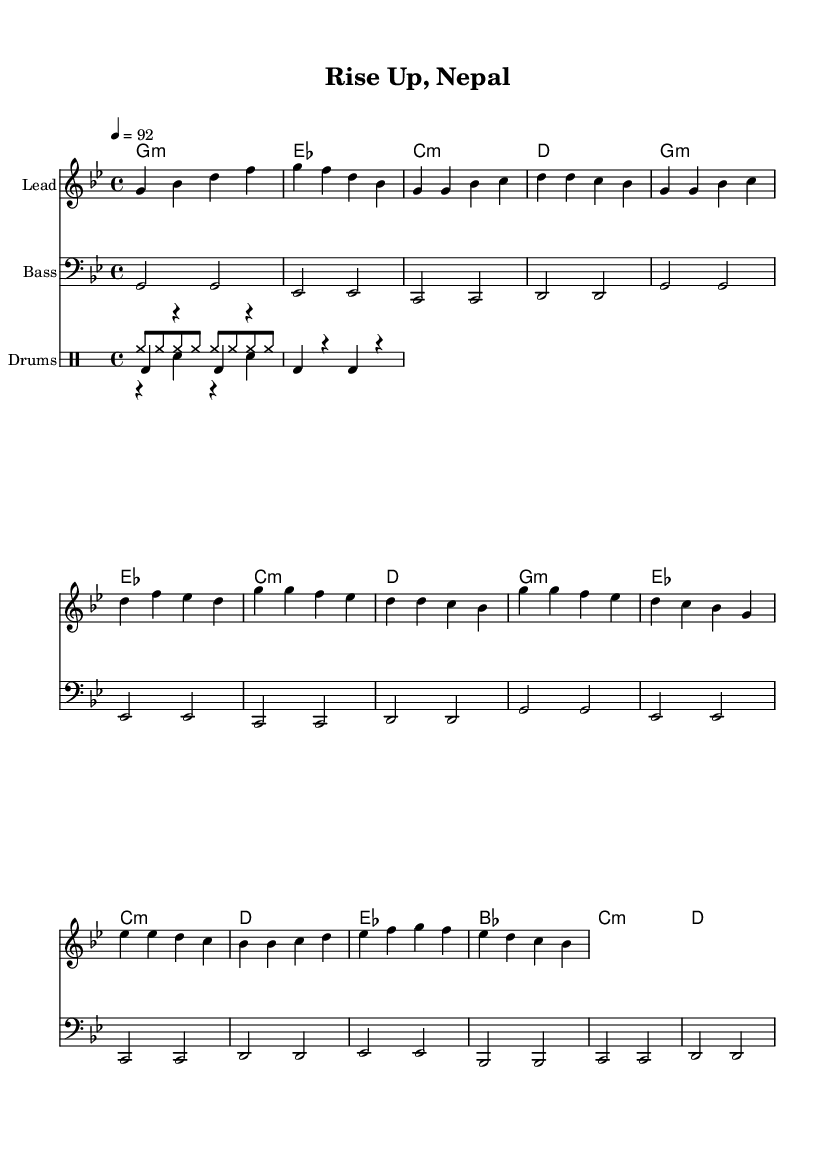What is the key signature of this music? The key signature is indicated at the beginning of the sheet music and shows two flats, which indicates B flat major or G minor.
Answer: G minor What is the time signature of the piece? The time signature is found at the beginning of the sheet music and is indicated as 4/4, meaning there are four beats in each measure, and the quarter note gets one beat.
Answer: 4/4 What is the tempo marking for this piece? The tempo marking is specified in the global section and indicates a speed of 92 beats per minute, meaning the piece should be played at this pace.
Answer: 92 How many measures are in the verse section? By counting the measures in the verse section as outlined in the melody part, there are four measures that represent the verse.
Answer: 4 What is the main chord used in the chorus? To identify the main chord, look at the harmonies section during the chorus which predominantly uses G minor, indicating its significance in this part of the piece.
Answer: G minor Is there a bridge section in this music? The presence of a bridge section is confirmed by examining the structure of the music, where specific measures align only with the bridge, indicating its distinct separation from other parts.
Answer: Yes 